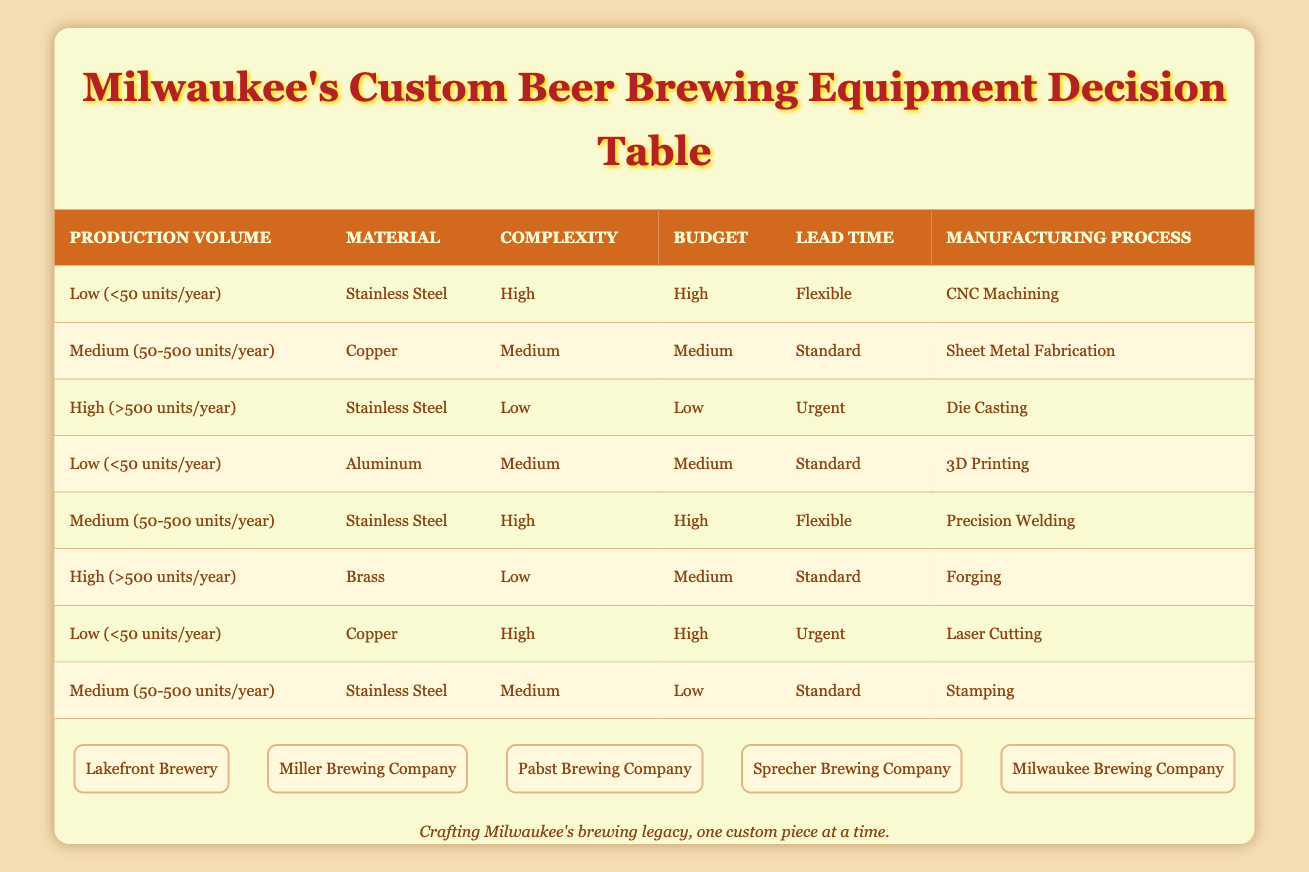What manufacturing process is used for high production volume with low complexity? The table shows that for a production volume categorized as high (>500 units/year) with low complexity, the manufacturing process is Die Casting.
Answer: Die Casting What is the manufacturing process for low production volume and high budget? According to the table, when the production volume is low (<50 units/year) and the budget is high, the manufacturing process is CNC Machining or Laser Cutting.
Answer: CNC Machining, Laser Cutting Is Precision Welding ever used for low budget projects? The table shows that Precision Welding corresponds to a medium production volume (50-500 units/year), high complexity, and high budget, which indicates that it is not used for low budget projects.
Answer: No What materials are used with the 3D Printing process? As per the table, 3D Printing is associated with aluminum as the material alongside a low production volume (less than 50 units/year) and medium complexity.
Answer: Aluminum What are the two manufacturing processes associated with high complexity? The table lists CNC Machining and Precision Welding as the manufacturing processes associated with high complexity. CNC Machining corresponds to low production volume and high budget, while Precision Welding corresponds to medium volume, medium budget.
Answer: CNC Machining, Precision Welding How many manufacturing processes are listed for low production volume? By examining the table, there are three manufacturing processes listed for low production volume (<50 units/year), such as CNC Machining, 3D Printing, and Laser Cutting, indicating multiple options for this category.
Answer: Three If a brewery needs medium lead time and high production volume, which process should they choose? The table indicates that for high production volume (>500 units/year) with an urgent lead time, the process is Die Casting. Since the brewery needs medium lead time, this requirement does not align with the process. There is no applicable process for medium lead time under the high production volume category.
Answer: None Which material is paired with the lowest budget in the medium production category? The table reveals that for medium production volume (50-500 units/year) with low budget, the manufacturing process listed is Stamping, which corresponds to stainless steel as the material.
Answer: Stainless Steel 